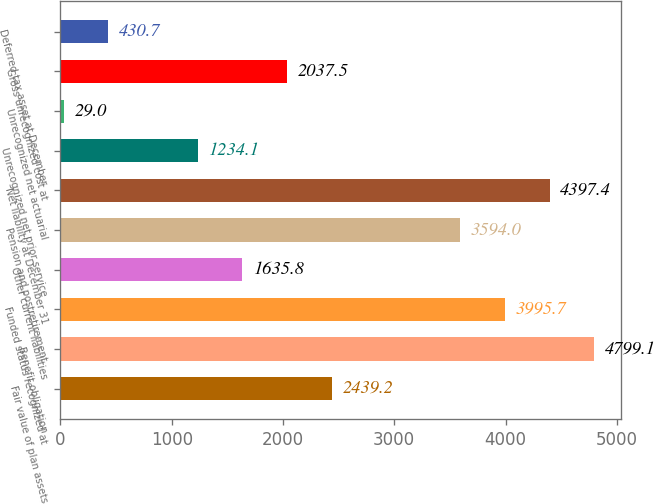Convert chart. <chart><loc_0><loc_0><loc_500><loc_500><bar_chart><fcel>Fair value of plan assets<fcel>Benefit obligation<fcel>Funded status recognized at<fcel>Other current liabilities<fcel>Pension and postretirement<fcel>Net liability at December 31<fcel>Unrecognized net prior service<fcel>Unrecognized net actuarial<fcel>Gross unrecognized cost at<fcel>Deferred tax asset at December<nl><fcel>2439.2<fcel>4799.1<fcel>3995.7<fcel>1635.8<fcel>3594<fcel>4397.4<fcel>1234.1<fcel>29<fcel>2037.5<fcel>430.7<nl></chart> 